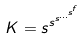<formula> <loc_0><loc_0><loc_500><loc_500>K = s ^ { s ^ { s ^ { \dots ^ { s ^ { f } } } } }</formula> 